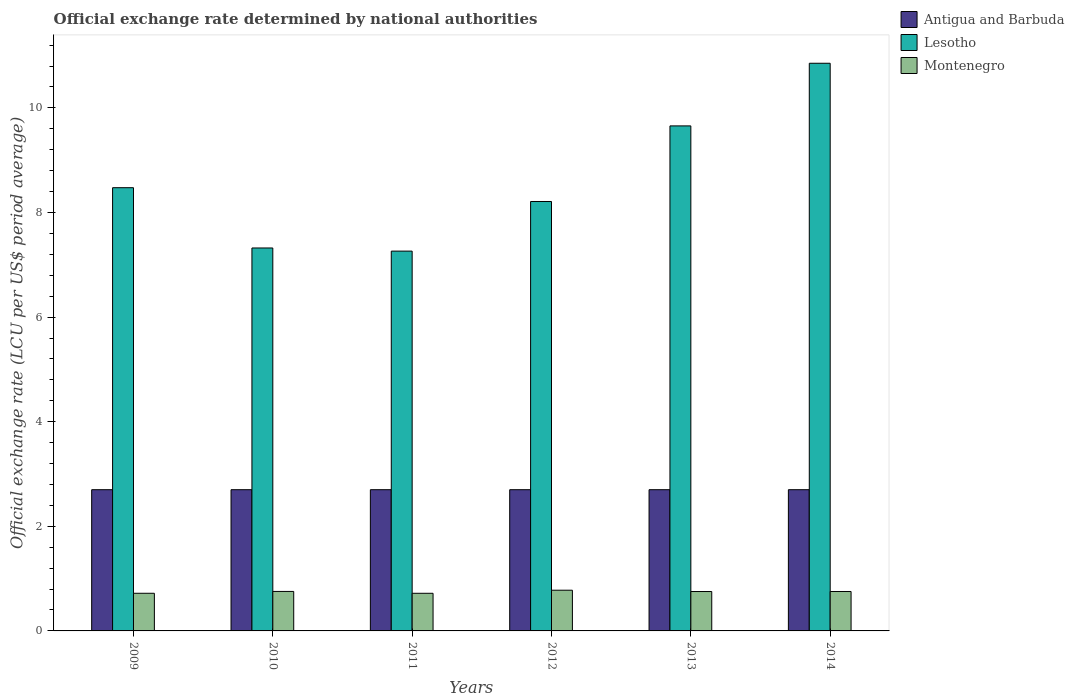How many different coloured bars are there?
Keep it short and to the point. 3. How many groups of bars are there?
Your response must be concise. 6. Are the number of bars per tick equal to the number of legend labels?
Your answer should be compact. Yes. How many bars are there on the 5th tick from the right?
Offer a terse response. 3. What is the label of the 2nd group of bars from the left?
Provide a short and direct response. 2010. In how many cases, is the number of bars for a given year not equal to the number of legend labels?
Keep it short and to the point. 0. Across all years, what is the maximum official exchange rate in Lesotho?
Provide a succinct answer. 10.85. Across all years, what is the minimum official exchange rate in Antigua and Barbuda?
Keep it short and to the point. 2.7. In which year was the official exchange rate in Montenegro maximum?
Offer a very short reply. 2012. In which year was the official exchange rate in Montenegro minimum?
Your response must be concise. 2011. What is the difference between the official exchange rate in Antigua and Barbuda in 2010 and the official exchange rate in Lesotho in 2009?
Offer a terse response. -5.77. What is the average official exchange rate in Montenegro per year?
Provide a succinct answer. 0.75. In the year 2012, what is the difference between the official exchange rate in Montenegro and official exchange rate in Lesotho?
Provide a succinct answer. -7.43. What is the ratio of the official exchange rate in Lesotho in 2010 to that in 2011?
Make the answer very short. 1.01. What is the difference between the highest and the second highest official exchange rate in Montenegro?
Make the answer very short. 0.02. What is the difference between the highest and the lowest official exchange rate in Lesotho?
Your response must be concise. 3.59. In how many years, is the official exchange rate in Antigua and Barbuda greater than the average official exchange rate in Antigua and Barbuda taken over all years?
Keep it short and to the point. 6. Is the sum of the official exchange rate in Lesotho in 2010 and 2012 greater than the maximum official exchange rate in Antigua and Barbuda across all years?
Provide a short and direct response. Yes. What does the 2nd bar from the left in 2010 represents?
Give a very brief answer. Lesotho. What does the 2nd bar from the right in 2014 represents?
Your answer should be compact. Lesotho. Is it the case that in every year, the sum of the official exchange rate in Montenegro and official exchange rate in Lesotho is greater than the official exchange rate in Antigua and Barbuda?
Give a very brief answer. Yes. How many years are there in the graph?
Make the answer very short. 6. Where does the legend appear in the graph?
Provide a succinct answer. Top right. What is the title of the graph?
Give a very brief answer. Official exchange rate determined by national authorities. What is the label or title of the Y-axis?
Offer a very short reply. Official exchange rate (LCU per US$ period average). What is the Official exchange rate (LCU per US$ period average) in Antigua and Barbuda in 2009?
Give a very brief answer. 2.7. What is the Official exchange rate (LCU per US$ period average) of Lesotho in 2009?
Offer a terse response. 8.47. What is the Official exchange rate (LCU per US$ period average) of Montenegro in 2009?
Make the answer very short. 0.72. What is the Official exchange rate (LCU per US$ period average) in Lesotho in 2010?
Your answer should be very brief. 7.32. What is the Official exchange rate (LCU per US$ period average) in Montenegro in 2010?
Your answer should be very brief. 0.76. What is the Official exchange rate (LCU per US$ period average) in Lesotho in 2011?
Ensure brevity in your answer.  7.26. What is the Official exchange rate (LCU per US$ period average) of Montenegro in 2011?
Give a very brief answer. 0.72. What is the Official exchange rate (LCU per US$ period average) in Antigua and Barbuda in 2012?
Make the answer very short. 2.7. What is the Official exchange rate (LCU per US$ period average) in Lesotho in 2012?
Ensure brevity in your answer.  8.21. What is the Official exchange rate (LCU per US$ period average) in Montenegro in 2012?
Your response must be concise. 0.78. What is the Official exchange rate (LCU per US$ period average) in Lesotho in 2013?
Ensure brevity in your answer.  9.66. What is the Official exchange rate (LCU per US$ period average) in Montenegro in 2013?
Provide a short and direct response. 0.75. What is the Official exchange rate (LCU per US$ period average) in Lesotho in 2014?
Ensure brevity in your answer.  10.85. What is the Official exchange rate (LCU per US$ period average) of Montenegro in 2014?
Keep it short and to the point. 0.75. Across all years, what is the maximum Official exchange rate (LCU per US$ period average) of Lesotho?
Provide a succinct answer. 10.85. Across all years, what is the maximum Official exchange rate (LCU per US$ period average) in Montenegro?
Your response must be concise. 0.78. Across all years, what is the minimum Official exchange rate (LCU per US$ period average) of Lesotho?
Your answer should be very brief. 7.26. Across all years, what is the minimum Official exchange rate (LCU per US$ period average) in Montenegro?
Provide a short and direct response. 0.72. What is the total Official exchange rate (LCU per US$ period average) of Antigua and Barbuda in the graph?
Provide a succinct answer. 16.2. What is the total Official exchange rate (LCU per US$ period average) of Lesotho in the graph?
Your response must be concise. 51.77. What is the total Official exchange rate (LCU per US$ period average) of Montenegro in the graph?
Give a very brief answer. 4.48. What is the difference between the Official exchange rate (LCU per US$ period average) of Lesotho in 2009 and that in 2010?
Ensure brevity in your answer.  1.15. What is the difference between the Official exchange rate (LCU per US$ period average) in Montenegro in 2009 and that in 2010?
Make the answer very short. -0.04. What is the difference between the Official exchange rate (LCU per US$ period average) in Antigua and Barbuda in 2009 and that in 2011?
Your response must be concise. 0. What is the difference between the Official exchange rate (LCU per US$ period average) in Lesotho in 2009 and that in 2011?
Provide a short and direct response. 1.21. What is the difference between the Official exchange rate (LCU per US$ period average) in Montenegro in 2009 and that in 2011?
Offer a very short reply. 0. What is the difference between the Official exchange rate (LCU per US$ period average) of Antigua and Barbuda in 2009 and that in 2012?
Offer a very short reply. 0. What is the difference between the Official exchange rate (LCU per US$ period average) of Lesotho in 2009 and that in 2012?
Your answer should be compact. 0.26. What is the difference between the Official exchange rate (LCU per US$ period average) of Montenegro in 2009 and that in 2012?
Ensure brevity in your answer.  -0.06. What is the difference between the Official exchange rate (LCU per US$ period average) in Antigua and Barbuda in 2009 and that in 2013?
Provide a succinct answer. 0. What is the difference between the Official exchange rate (LCU per US$ period average) of Lesotho in 2009 and that in 2013?
Your response must be concise. -1.18. What is the difference between the Official exchange rate (LCU per US$ period average) in Montenegro in 2009 and that in 2013?
Ensure brevity in your answer.  -0.03. What is the difference between the Official exchange rate (LCU per US$ period average) of Lesotho in 2009 and that in 2014?
Give a very brief answer. -2.38. What is the difference between the Official exchange rate (LCU per US$ period average) in Montenegro in 2009 and that in 2014?
Ensure brevity in your answer.  -0.03. What is the difference between the Official exchange rate (LCU per US$ period average) in Lesotho in 2010 and that in 2011?
Provide a short and direct response. 0.06. What is the difference between the Official exchange rate (LCU per US$ period average) in Montenegro in 2010 and that in 2011?
Offer a very short reply. 0.04. What is the difference between the Official exchange rate (LCU per US$ period average) of Antigua and Barbuda in 2010 and that in 2012?
Keep it short and to the point. 0. What is the difference between the Official exchange rate (LCU per US$ period average) in Lesotho in 2010 and that in 2012?
Ensure brevity in your answer.  -0.89. What is the difference between the Official exchange rate (LCU per US$ period average) of Montenegro in 2010 and that in 2012?
Make the answer very short. -0.02. What is the difference between the Official exchange rate (LCU per US$ period average) of Lesotho in 2010 and that in 2013?
Your answer should be very brief. -2.33. What is the difference between the Official exchange rate (LCU per US$ period average) in Montenegro in 2010 and that in 2013?
Offer a very short reply. 0. What is the difference between the Official exchange rate (LCU per US$ period average) in Antigua and Barbuda in 2010 and that in 2014?
Your answer should be very brief. 0. What is the difference between the Official exchange rate (LCU per US$ period average) in Lesotho in 2010 and that in 2014?
Make the answer very short. -3.53. What is the difference between the Official exchange rate (LCU per US$ period average) in Montenegro in 2010 and that in 2014?
Provide a succinct answer. 0. What is the difference between the Official exchange rate (LCU per US$ period average) in Antigua and Barbuda in 2011 and that in 2012?
Give a very brief answer. 0. What is the difference between the Official exchange rate (LCU per US$ period average) of Lesotho in 2011 and that in 2012?
Give a very brief answer. -0.95. What is the difference between the Official exchange rate (LCU per US$ period average) of Montenegro in 2011 and that in 2012?
Offer a very short reply. -0.06. What is the difference between the Official exchange rate (LCU per US$ period average) of Antigua and Barbuda in 2011 and that in 2013?
Keep it short and to the point. 0. What is the difference between the Official exchange rate (LCU per US$ period average) in Lesotho in 2011 and that in 2013?
Provide a succinct answer. -2.39. What is the difference between the Official exchange rate (LCU per US$ period average) of Montenegro in 2011 and that in 2013?
Ensure brevity in your answer.  -0.03. What is the difference between the Official exchange rate (LCU per US$ period average) of Antigua and Barbuda in 2011 and that in 2014?
Your response must be concise. 0. What is the difference between the Official exchange rate (LCU per US$ period average) of Lesotho in 2011 and that in 2014?
Your answer should be very brief. -3.59. What is the difference between the Official exchange rate (LCU per US$ period average) of Montenegro in 2011 and that in 2014?
Offer a very short reply. -0.03. What is the difference between the Official exchange rate (LCU per US$ period average) in Lesotho in 2012 and that in 2013?
Provide a succinct answer. -1.45. What is the difference between the Official exchange rate (LCU per US$ period average) in Montenegro in 2012 and that in 2013?
Ensure brevity in your answer.  0.03. What is the difference between the Official exchange rate (LCU per US$ period average) in Lesotho in 2012 and that in 2014?
Make the answer very short. -2.64. What is the difference between the Official exchange rate (LCU per US$ period average) in Montenegro in 2012 and that in 2014?
Ensure brevity in your answer.  0.02. What is the difference between the Official exchange rate (LCU per US$ period average) in Antigua and Barbuda in 2013 and that in 2014?
Your answer should be compact. 0. What is the difference between the Official exchange rate (LCU per US$ period average) in Lesotho in 2013 and that in 2014?
Your answer should be compact. -1.2. What is the difference between the Official exchange rate (LCU per US$ period average) of Montenegro in 2013 and that in 2014?
Keep it short and to the point. -0. What is the difference between the Official exchange rate (LCU per US$ period average) of Antigua and Barbuda in 2009 and the Official exchange rate (LCU per US$ period average) of Lesotho in 2010?
Your response must be concise. -4.62. What is the difference between the Official exchange rate (LCU per US$ period average) of Antigua and Barbuda in 2009 and the Official exchange rate (LCU per US$ period average) of Montenegro in 2010?
Make the answer very short. 1.95. What is the difference between the Official exchange rate (LCU per US$ period average) in Lesotho in 2009 and the Official exchange rate (LCU per US$ period average) in Montenegro in 2010?
Your response must be concise. 7.72. What is the difference between the Official exchange rate (LCU per US$ period average) of Antigua and Barbuda in 2009 and the Official exchange rate (LCU per US$ period average) of Lesotho in 2011?
Provide a succinct answer. -4.56. What is the difference between the Official exchange rate (LCU per US$ period average) in Antigua and Barbuda in 2009 and the Official exchange rate (LCU per US$ period average) in Montenegro in 2011?
Your answer should be compact. 1.98. What is the difference between the Official exchange rate (LCU per US$ period average) in Lesotho in 2009 and the Official exchange rate (LCU per US$ period average) in Montenegro in 2011?
Make the answer very short. 7.75. What is the difference between the Official exchange rate (LCU per US$ period average) in Antigua and Barbuda in 2009 and the Official exchange rate (LCU per US$ period average) in Lesotho in 2012?
Provide a succinct answer. -5.51. What is the difference between the Official exchange rate (LCU per US$ period average) of Antigua and Barbuda in 2009 and the Official exchange rate (LCU per US$ period average) of Montenegro in 2012?
Offer a very short reply. 1.92. What is the difference between the Official exchange rate (LCU per US$ period average) of Lesotho in 2009 and the Official exchange rate (LCU per US$ period average) of Montenegro in 2012?
Provide a succinct answer. 7.7. What is the difference between the Official exchange rate (LCU per US$ period average) of Antigua and Barbuda in 2009 and the Official exchange rate (LCU per US$ period average) of Lesotho in 2013?
Your response must be concise. -6.96. What is the difference between the Official exchange rate (LCU per US$ period average) in Antigua and Barbuda in 2009 and the Official exchange rate (LCU per US$ period average) in Montenegro in 2013?
Ensure brevity in your answer.  1.95. What is the difference between the Official exchange rate (LCU per US$ period average) of Lesotho in 2009 and the Official exchange rate (LCU per US$ period average) of Montenegro in 2013?
Offer a terse response. 7.72. What is the difference between the Official exchange rate (LCU per US$ period average) of Antigua and Barbuda in 2009 and the Official exchange rate (LCU per US$ period average) of Lesotho in 2014?
Your answer should be very brief. -8.15. What is the difference between the Official exchange rate (LCU per US$ period average) in Antigua and Barbuda in 2009 and the Official exchange rate (LCU per US$ period average) in Montenegro in 2014?
Your answer should be compact. 1.95. What is the difference between the Official exchange rate (LCU per US$ period average) in Lesotho in 2009 and the Official exchange rate (LCU per US$ period average) in Montenegro in 2014?
Offer a very short reply. 7.72. What is the difference between the Official exchange rate (LCU per US$ period average) in Antigua and Barbuda in 2010 and the Official exchange rate (LCU per US$ period average) in Lesotho in 2011?
Offer a terse response. -4.56. What is the difference between the Official exchange rate (LCU per US$ period average) in Antigua and Barbuda in 2010 and the Official exchange rate (LCU per US$ period average) in Montenegro in 2011?
Keep it short and to the point. 1.98. What is the difference between the Official exchange rate (LCU per US$ period average) in Lesotho in 2010 and the Official exchange rate (LCU per US$ period average) in Montenegro in 2011?
Make the answer very short. 6.6. What is the difference between the Official exchange rate (LCU per US$ period average) in Antigua and Barbuda in 2010 and the Official exchange rate (LCU per US$ period average) in Lesotho in 2012?
Provide a short and direct response. -5.51. What is the difference between the Official exchange rate (LCU per US$ period average) of Antigua and Barbuda in 2010 and the Official exchange rate (LCU per US$ period average) of Montenegro in 2012?
Your answer should be very brief. 1.92. What is the difference between the Official exchange rate (LCU per US$ period average) of Lesotho in 2010 and the Official exchange rate (LCU per US$ period average) of Montenegro in 2012?
Your answer should be compact. 6.54. What is the difference between the Official exchange rate (LCU per US$ period average) of Antigua and Barbuda in 2010 and the Official exchange rate (LCU per US$ period average) of Lesotho in 2013?
Give a very brief answer. -6.96. What is the difference between the Official exchange rate (LCU per US$ period average) of Antigua and Barbuda in 2010 and the Official exchange rate (LCU per US$ period average) of Montenegro in 2013?
Ensure brevity in your answer.  1.95. What is the difference between the Official exchange rate (LCU per US$ period average) of Lesotho in 2010 and the Official exchange rate (LCU per US$ period average) of Montenegro in 2013?
Keep it short and to the point. 6.57. What is the difference between the Official exchange rate (LCU per US$ period average) in Antigua and Barbuda in 2010 and the Official exchange rate (LCU per US$ period average) in Lesotho in 2014?
Keep it short and to the point. -8.15. What is the difference between the Official exchange rate (LCU per US$ period average) of Antigua and Barbuda in 2010 and the Official exchange rate (LCU per US$ period average) of Montenegro in 2014?
Your response must be concise. 1.95. What is the difference between the Official exchange rate (LCU per US$ period average) in Lesotho in 2010 and the Official exchange rate (LCU per US$ period average) in Montenegro in 2014?
Provide a succinct answer. 6.57. What is the difference between the Official exchange rate (LCU per US$ period average) of Antigua and Barbuda in 2011 and the Official exchange rate (LCU per US$ period average) of Lesotho in 2012?
Provide a short and direct response. -5.51. What is the difference between the Official exchange rate (LCU per US$ period average) in Antigua and Barbuda in 2011 and the Official exchange rate (LCU per US$ period average) in Montenegro in 2012?
Your answer should be compact. 1.92. What is the difference between the Official exchange rate (LCU per US$ period average) in Lesotho in 2011 and the Official exchange rate (LCU per US$ period average) in Montenegro in 2012?
Give a very brief answer. 6.48. What is the difference between the Official exchange rate (LCU per US$ period average) in Antigua and Barbuda in 2011 and the Official exchange rate (LCU per US$ period average) in Lesotho in 2013?
Keep it short and to the point. -6.96. What is the difference between the Official exchange rate (LCU per US$ period average) of Antigua and Barbuda in 2011 and the Official exchange rate (LCU per US$ period average) of Montenegro in 2013?
Your answer should be very brief. 1.95. What is the difference between the Official exchange rate (LCU per US$ period average) of Lesotho in 2011 and the Official exchange rate (LCU per US$ period average) of Montenegro in 2013?
Your response must be concise. 6.51. What is the difference between the Official exchange rate (LCU per US$ period average) of Antigua and Barbuda in 2011 and the Official exchange rate (LCU per US$ period average) of Lesotho in 2014?
Offer a very short reply. -8.15. What is the difference between the Official exchange rate (LCU per US$ period average) of Antigua and Barbuda in 2011 and the Official exchange rate (LCU per US$ period average) of Montenegro in 2014?
Offer a very short reply. 1.95. What is the difference between the Official exchange rate (LCU per US$ period average) of Lesotho in 2011 and the Official exchange rate (LCU per US$ period average) of Montenegro in 2014?
Offer a terse response. 6.51. What is the difference between the Official exchange rate (LCU per US$ period average) in Antigua and Barbuda in 2012 and the Official exchange rate (LCU per US$ period average) in Lesotho in 2013?
Your answer should be compact. -6.96. What is the difference between the Official exchange rate (LCU per US$ period average) of Antigua and Barbuda in 2012 and the Official exchange rate (LCU per US$ period average) of Montenegro in 2013?
Your answer should be compact. 1.95. What is the difference between the Official exchange rate (LCU per US$ period average) in Lesotho in 2012 and the Official exchange rate (LCU per US$ period average) in Montenegro in 2013?
Your answer should be very brief. 7.46. What is the difference between the Official exchange rate (LCU per US$ period average) in Antigua and Barbuda in 2012 and the Official exchange rate (LCU per US$ period average) in Lesotho in 2014?
Your answer should be compact. -8.15. What is the difference between the Official exchange rate (LCU per US$ period average) in Antigua and Barbuda in 2012 and the Official exchange rate (LCU per US$ period average) in Montenegro in 2014?
Offer a terse response. 1.95. What is the difference between the Official exchange rate (LCU per US$ period average) in Lesotho in 2012 and the Official exchange rate (LCU per US$ period average) in Montenegro in 2014?
Offer a very short reply. 7.46. What is the difference between the Official exchange rate (LCU per US$ period average) of Antigua and Barbuda in 2013 and the Official exchange rate (LCU per US$ period average) of Lesotho in 2014?
Give a very brief answer. -8.15. What is the difference between the Official exchange rate (LCU per US$ period average) of Antigua and Barbuda in 2013 and the Official exchange rate (LCU per US$ period average) of Montenegro in 2014?
Your answer should be compact. 1.95. What is the difference between the Official exchange rate (LCU per US$ period average) of Lesotho in 2013 and the Official exchange rate (LCU per US$ period average) of Montenegro in 2014?
Keep it short and to the point. 8.9. What is the average Official exchange rate (LCU per US$ period average) of Antigua and Barbuda per year?
Offer a very short reply. 2.7. What is the average Official exchange rate (LCU per US$ period average) of Lesotho per year?
Your answer should be compact. 8.63. What is the average Official exchange rate (LCU per US$ period average) of Montenegro per year?
Ensure brevity in your answer.  0.75. In the year 2009, what is the difference between the Official exchange rate (LCU per US$ period average) in Antigua and Barbuda and Official exchange rate (LCU per US$ period average) in Lesotho?
Ensure brevity in your answer.  -5.77. In the year 2009, what is the difference between the Official exchange rate (LCU per US$ period average) in Antigua and Barbuda and Official exchange rate (LCU per US$ period average) in Montenegro?
Provide a succinct answer. 1.98. In the year 2009, what is the difference between the Official exchange rate (LCU per US$ period average) of Lesotho and Official exchange rate (LCU per US$ period average) of Montenegro?
Provide a succinct answer. 7.75. In the year 2010, what is the difference between the Official exchange rate (LCU per US$ period average) of Antigua and Barbuda and Official exchange rate (LCU per US$ period average) of Lesotho?
Provide a succinct answer. -4.62. In the year 2010, what is the difference between the Official exchange rate (LCU per US$ period average) in Antigua and Barbuda and Official exchange rate (LCU per US$ period average) in Montenegro?
Keep it short and to the point. 1.95. In the year 2010, what is the difference between the Official exchange rate (LCU per US$ period average) of Lesotho and Official exchange rate (LCU per US$ period average) of Montenegro?
Make the answer very short. 6.57. In the year 2011, what is the difference between the Official exchange rate (LCU per US$ period average) in Antigua and Barbuda and Official exchange rate (LCU per US$ period average) in Lesotho?
Give a very brief answer. -4.56. In the year 2011, what is the difference between the Official exchange rate (LCU per US$ period average) in Antigua and Barbuda and Official exchange rate (LCU per US$ period average) in Montenegro?
Make the answer very short. 1.98. In the year 2011, what is the difference between the Official exchange rate (LCU per US$ period average) in Lesotho and Official exchange rate (LCU per US$ period average) in Montenegro?
Make the answer very short. 6.54. In the year 2012, what is the difference between the Official exchange rate (LCU per US$ period average) of Antigua and Barbuda and Official exchange rate (LCU per US$ period average) of Lesotho?
Give a very brief answer. -5.51. In the year 2012, what is the difference between the Official exchange rate (LCU per US$ period average) in Antigua and Barbuda and Official exchange rate (LCU per US$ period average) in Montenegro?
Your answer should be very brief. 1.92. In the year 2012, what is the difference between the Official exchange rate (LCU per US$ period average) in Lesotho and Official exchange rate (LCU per US$ period average) in Montenegro?
Keep it short and to the point. 7.43. In the year 2013, what is the difference between the Official exchange rate (LCU per US$ period average) of Antigua and Barbuda and Official exchange rate (LCU per US$ period average) of Lesotho?
Your response must be concise. -6.96. In the year 2013, what is the difference between the Official exchange rate (LCU per US$ period average) in Antigua and Barbuda and Official exchange rate (LCU per US$ period average) in Montenegro?
Your answer should be compact. 1.95. In the year 2013, what is the difference between the Official exchange rate (LCU per US$ period average) in Lesotho and Official exchange rate (LCU per US$ period average) in Montenegro?
Provide a succinct answer. 8.9. In the year 2014, what is the difference between the Official exchange rate (LCU per US$ period average) in Antigua and Barbuda and Official exchange rate (LCU per US$ period average) in Lesotho?
Give a very brief answer. -8.15. In the year 2014, what is the difference between the Official exchange rate (LCU per US$ period average) in Antigua and Barbuda and Official exchange rate (LCU per US$ period average) in Montenegro?
Provide a short and direct response. 1.95. In the year 2014, what is the difference between the Official exchange rate (LCU per US$ period average) in Lesotho and Official exchange rate (LCU per US$ period average) in Montenegro?
Keep it short and to the point. 10.1. What is the ratio of the Official exchange rate (LCU per US$ period average) of Lesotho in 2009 to that in 2010?
Your answer should be very brief. 1.16. What is the ratio of the Official exchange rate (LCU per US$ period average) of Montenegro in 2009 to that in 2010?
Make the answer very short. 0.95. What is the ratio of the Official exchange rate (LCU per US$ period average) of Lesotho in 2009 to that in 2011?
Your response must be concise. 1.17. What is the ratio of the Official exchange rate (LCU per US$ period average) of Montenegro in 2009 to that in 2011?
Your answer should be very brief. 1. What is the ratio of the Official exchange rate (LCU per US$ period average) of Lesotho in 2009 to that in 2012?
Your answer should be very brief. 1.03. What is the ratio of the Official exchange rate (LCU per US$ period average) of Montenegro in 2009 to that in 2012?
Your answer should be very brief. 0.92. What is the ratio of the Official exchange rate (LCU per US$ period average) in Antigua and Barbuda in 2009 to that in 2013?
Your response must be concise. 1. What is the ratio of the Official exchange rate (LCU per US$ period average) of Lesotho in 2009 to that in 2013?
Offer a very short reply. 0.88. What is the ratio of the Official exchange rate (LCU per US$ period average) of Montenegro in 2009 to that in 2013?
Your response must be concise. 0.96. What is the ratio of the Official exchange rate (LCU per US$ period average) in Antigua and Barbuda in 2009 to that in 2014?
Your answer should be very brief. 1. What is the ratio of the Official exchange rate (LCU per US$ period average) of Lesotho in 2009 to that in 2014?
Offer a terse response. 0.78. What is the ratio of the Official exchange rate (LCU per US$ period average) in Montenegro in 2009 to that in 2014?
Your answer should be very brief. 0.95. What is the ratio of the Official exchange rate (LCU per US$ period average) of Antigua and Barbuda in 2010 to that in 2011?
Offer a terse response. 1. What is the ratio of the Official exchange rate (LCU per US$ period average) of Lesotho in 2010 to that in 2011?
Your response must be concise. 1.01. What is the ratio of the Official exchange rate (LCU per US$ period average) in Montenegro in 2010 to that in 2011?
Make the answer very short. 1.05. What is the ratio of the Official exchange rate (LCU per US$ period average) in Lesotho in 2010 to that in 2012?
Offer a very short reply. 0.89. What is the ratio of the Official exchange rate (LCU per US$ period average) in Montenegro in 2010 to that in 2012?
Offer a very short reply. 0.97. What is the ratio of the Official exchange rate (LCU per US$ period average) in Antigua and Barbuda in 2010 to that in 2013?
Keep it short and to the point. 1. What is the ratio of the Official exchange rate (LCU per US$ period average) of Lesotho in 2010 to that in 2013?
Give a very brief answer. 0.76. What is the ratio of the Official exchange rate (LCU per US$ period average) of Montenegro in 2010 to that in 2013?
Offer a terse response. 1. What is the ratio of the Official exchange rate (LCU per US$ period average) of Lesotho in 2010 to that in 2014?
Provide a short and direct response. 0.67. What is the ratio of the Official exchange rate (LCU per US$ period average) of Antigua and Barbuda in 2011 to that in 2012?
Your answer should be very brief. 1. What is the ratio of the Official exchange rate (LCU per US$ period average) of Lesotho in 2011 to that in 2012?
Your answer should be compact. 0.88. What is the ratio of the Official exchange rate (LCU per US$ period average) of Montenegro in 2011 to that in 2012?
Your answer should be compact. 0.92. What is the ratio of the Official exchange rate (LCU per US$ period average) in Lesotho in 2011 to that in 2013?
Your answer should be compact. 0.75. What is the ratio of the Official exchange rate (LCU per US$ period average) of Montenegro in 2011 to that in 2013?
Your answer should be very brief. 0.96. What is the ratio of the Official exchange rate (LCU per US$ period average) in Lesotho in 2011 to that in 2014?
Your response must be concise. 0.67. What is the ratio of the Official exchange rate (LCU per US$ period average) in Montenegro in 2011 to that in 2014?
Your answer should be compact. 0.95. What is the ratio of the Official exchange rate (LCU per US$ period average) of Antigua and Barbuda in 2012 to that in 2013?
Your response must be concise. 1. What is the ratio of the Official exchange rate (LCU per US$ period average) in Lesotho in 2012 to that in 2013?
Offer a terse response. 0.85. What is the ratio of the Official exchange rate (LCU per US$ period average) in Montenegro in 2012 to that in 2013?
Provide a succinct answer. 1.03. What is the ratio of the Official exchange rate (LCU per US$ period average) of Antigua and Barbuda in 2012 to that in 2014?
Keep it short and to the point. 1. What is the ratio of the Official exchange rate (LCU per US$ period average) of Lesotho in 2012 to that in 2014?
Offer a terse response. 0.76. What is the ratio of the Official exchange rate (LCU per US$ period average) of Montenegro in 2012 to that in 2014?
Make the answer very short. 1.03. What is the ratio of the Official exchange rate (LCU per US$ period average) in Antigua and Barbuda in 2013 to that in 2014?
Keep it short and to the point. 1. What is the ratio of the Official exchange rate (LCU per US$ period average) of Lesotho in 2013 to that in 2014?
Offer a terse response. 0.89. What is the ratio of the Official exchange rate (LCU per US$ period average) in Montenegro in 2013 to that in 2014?
Offer a terse response. 1. What is the difference between the highest and the second highest Official exchange rate (LCU per US$ period average) in Lesotho?
Your answer should be very brief. 1.2. What is the difference between the highest and the second highest Official exchange rate (LCU per US$ period average) of Montenegro?
Your answer should be very brief. 0.02. What is the difference between the highest and the lowest Official exchange rate (LCU per US$ period average) in Lesotho?
Your answer should be compact. 3.59. What is the difference between the highest and the lowest Official exchange rate (LCU per US$ period average) of Montenegro?
Your answer should be compact. 0.06. 